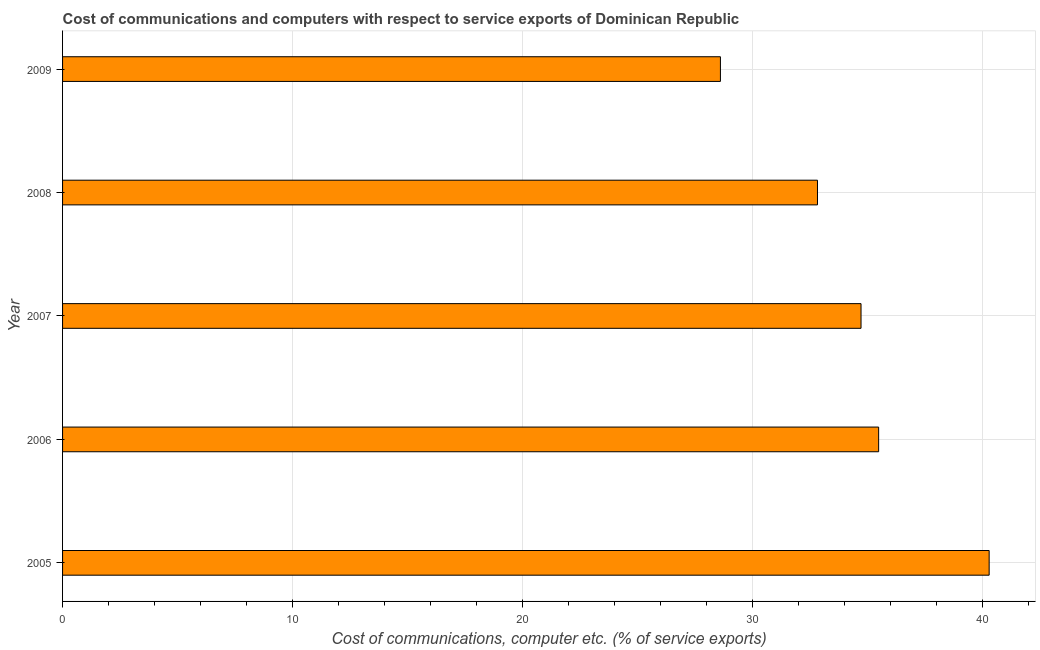Does the graph contain grids?
Ensure brevity in your answer.  Yes. What is the title of the graph?
Give a very brief answer. Cost of communications and computers with respect to service exports of Dominican Republic. What is the label or title of the X-axis?
Your answer should be compact. Cost of communications, computer etc. (% of service exports). What is the cost of communications and computer in 2009?
Give a very brief answer. 28.6. Across all years, what is the maximum cost of communications and computer?
Keep it short and to the point. 40.28. Across all years, what is the minimum cost of communications and computer?
Provide a succinct answer. 28.6. In which year was the cost of communications and computer maximum?
Provide a short and direct response. 2005. In which year was the cost of communications and computer minimum?
Offer a very short reply. 2009. What is the sum of the cost of communications and computer?
Provide a short and direct response. 171.9. What is the difference between the cost of communications and computer in 2005 and 2007?
Provide a succinct answer. 5.57. What is the average cost of communications and computer per year?
Give a very brief answer. 34.38. What is the median cost of communications and computer?
Ensure brevity in your answer.  34.71. Do a majority of the years between 2008 and 2006 (inclusive) have cost of communications and computer greater than 26 %?
Make the answer very short. Yes. What is the ratio of the cost of communications and computer in 2006 to that in 2009?
Offer a very short reply. 1.24. Is the cost of communications and computer in 2007 less than that in 2008?
Provide a short and direct response. No. Is the difference between the cost of communications and computer in 2005 and 2007 greater than the difference between any two years?
Provide a succinct answer. No. What is the difference between the highest and the second highest cost of communications and computer?
Offer a very short reply. 4.8. What is the difference between the highest and the lowest cost of communications and computer?
Offer a terse response. 11.68. In how many years, is the cost of communications and computer greater than the average cost of communications and computer taken over all years?
Make the answer very short. 3. Are all the bars in the graph horizontal?
Your response must be concise. Yes. Are the values on the major ticks of X-axis written in scientific E-notation?
Keep it short and to the point. No. What is the Cost of communications, computer etc. (% of service exports) of 2005?
Offer a very short reply. 40.28. What is the Cost of communications, computer etc. (% of service exports) in 2006?
Keep it short and to the point. 35.48. What is the Cost of communications, computer etc. (% of service exports) in 2007?
Your answer should be very brief. 34.71. What is the Cost of communications, computer etc. (% of service exports) in 2008?
Ensure brevity in your answer.  32.82. What is the Cost of communications, computer etc. (% of service exports) in 2009?
Ensure brevity in your answer.  28.6. What is the difference between the Cost of communications, computer etc. (% of service exports) in 2005 and 2006?
Your response must be concise. 4.81. What is the difference between the Cost of communications, computer etc. (% of service exports) in 2005 and 2007?
Offer a terse response. 5.57. What is the difference between the Cost of communications, computer etc. (% of service exports) in 2005 and 2008?
Your answer should be very brief. 7.46. What is the difference between the Cost of communications, computer etc. (% of service exports) in 2005 and 2009?
Give a very brief answer. 11.68. What is the difference between the Cost of communications, computer etc. (% of service exports) in 2006 and 2007?
Your answer should be very brief. 0.77. What is the difference between the Cost of communications, computer etc. (% of service exports) in 2006 and 2008?
Offer a terse response. 2.66. What is the difference between the Cost of communications, computer etc. (% of service exports) in 2006 and 2009?
Your answer should be very brief. 6.88. What is the difference between the Cost of communications, computer etc. (% of service exports) in 2007 and 2008?
Make the answer very short. 1.89. What is the difference between the Cost of communications, computer etc. (% of service exports) in 2007 and 2009?
Give a very brief answer. 6.11. What is the difference between the Cost of communications, computer etc. (% of service exports) in 2008 and 2009?
Your answer should be compact. 4.22. What is the ratio of the Cost of communications, computer etc. (% of service exports) in 2005 to that in 2006?
Offer a terse response. 1.14. What is the ratio of the Cost of communications, computer etc. (% of service exports) in 2005 to that in 2007?
Keep it short and to the point. 1.16. What is the ratio of the Cost of communications, computer etc. (% of service exports) in 2005 to that in 2008?
Your answer should be very brief. 1.23. What is the ratio of the Cost of communications, computer etc. (% of service exports) in 2005 to that in 2009?
Ensure brevity in your answer.  1.41. What is the ratio of the Cost of communications, computer etc. (% of service exports) in 2006 to that in 2008?
Offer a terse response. 1.08. What is the ratio of the Cost of communications, computer etc. (% of service exports) in 2006 to that in 2009?
Your answer should be very brief. 1.24. What is the ratio of the Cost of communications, computer etc. (% of service exports) in 2007 to that in 2008?
Keep it short and to the point. 1.06. What is the ratio of the Cost of communications, computer etc. (% of service exports) in 2007 to that in 2009?
Provide a short and direct response. 1.21. What is the ratio of the Cost of communications, computer etc. (% of service exports) in 2008 to that in 2009?
Make the answer very short. 1.15. 